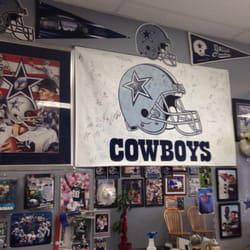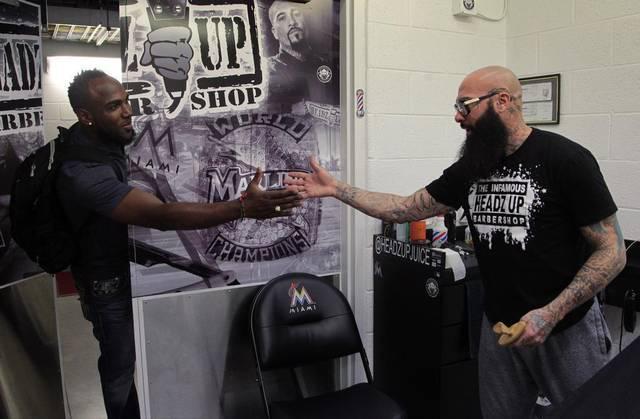The first image is the image on the left, the second image is the image on the right. For the images displayed, is the sentence "An image shows two young boys standing side-by-side and facing forward." factually correct? Answer yes or no. No. The first image is the image on the left, the second image is the image on the right. Analyze the images presented: Is the assertion "In at least one image there are two boys side by side in a barber shop." valid? Answer yes or no. No. 